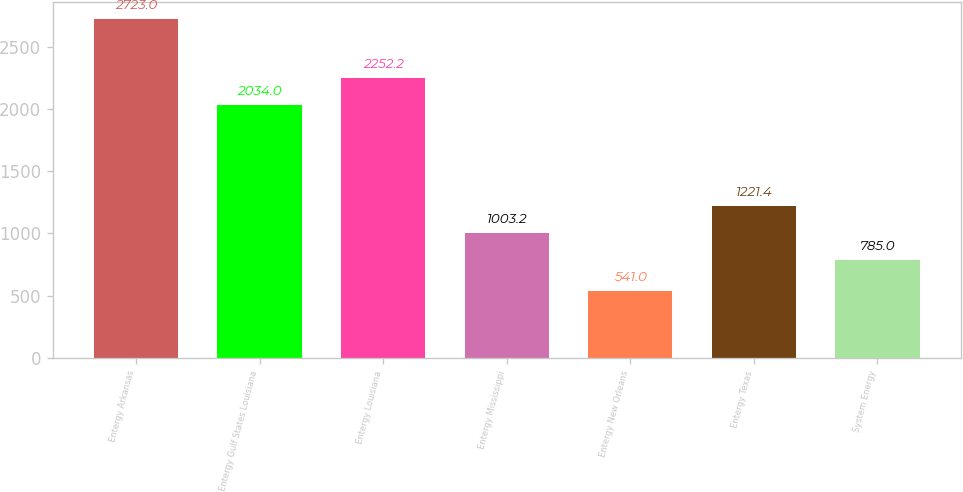Convert chart to OTSL. <chart><loc_0><loc_0><loc_500><loc_500><bar_chart><fcel>Entergy Arkansas<fcel>Entergy Gulf States Louisiana<fcel>Entergy Louisiana<fcel>Entergy Mississippi<fcel>Entergy New Orleans<fcel>Entergy Texas<fcel>System Energy<nl><fcel>2723<fcel>2034<fcel>2252.2<fcel>1003.2<fcel>541<fcel>1221.4<fcel>785<nl></chart> 